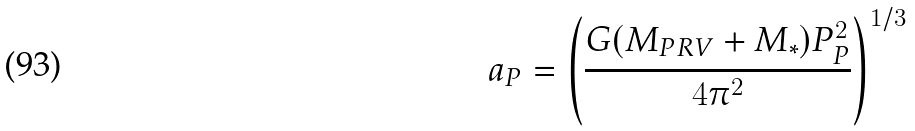<formula> <loc_0><loc_0><loc_500><loc_500>a _ { P } = \left ( \frac { G ( M _ { P R V } + M _ { * } ) P _ { P } ^ { 2 } } { 4 \pi ^ { 2 } } \right ) ^ { 1 / 3 }</formula> 